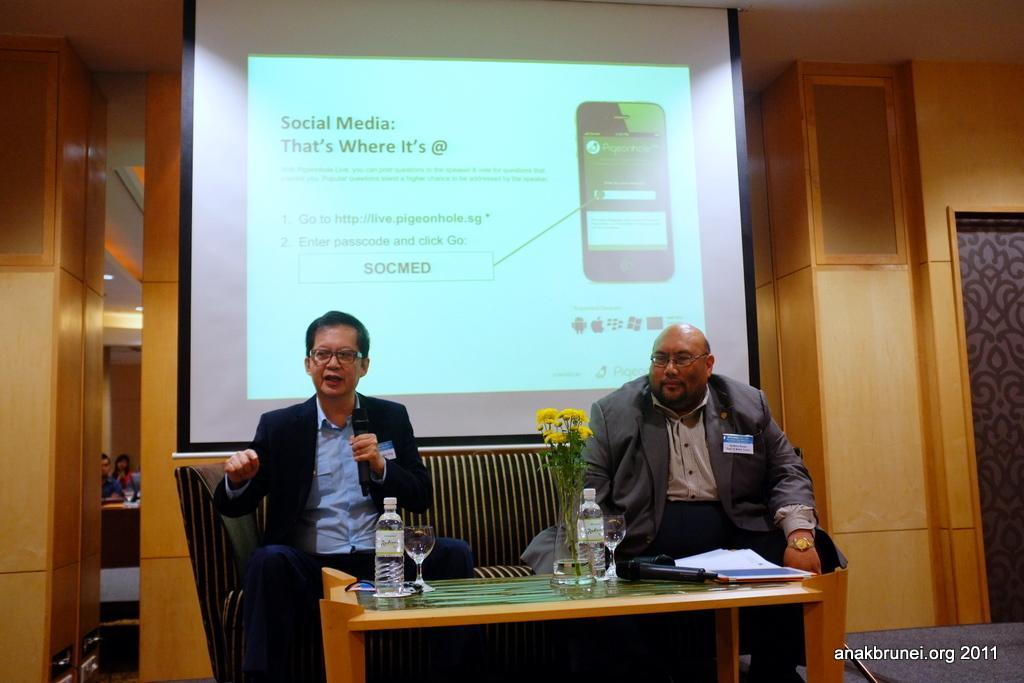Please provide a concise description of this image. In this image we can see two persons sitting on a sofa. They are wearing a suit and the person who is on the left side holding a microphone in his and he is speaking. In the background we can see a screen. 